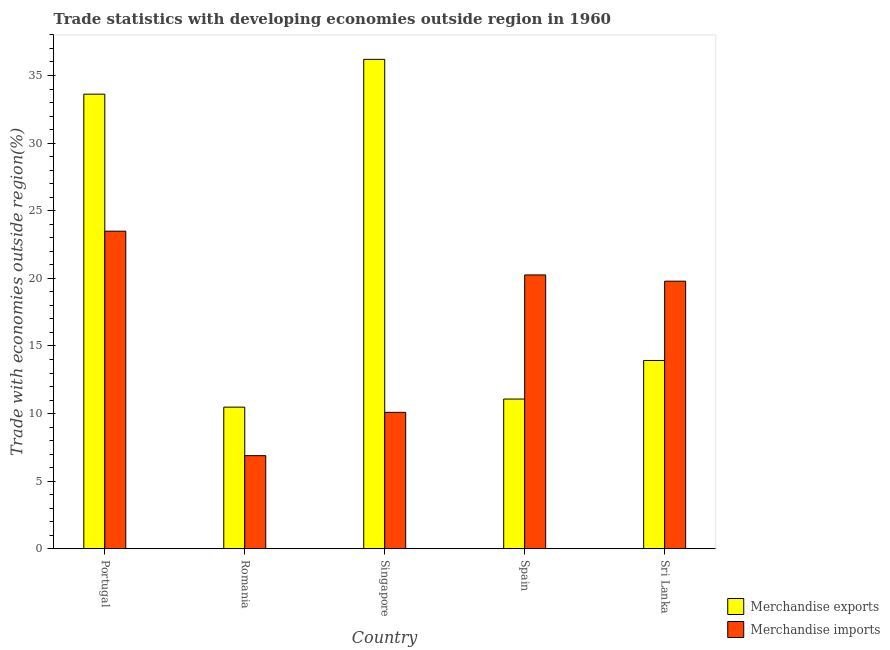How many bars are there on the 4th tick from the left?
Provide a short and direct response. 2. What is the label of the 5th group of bars from the left?
Provide a succinct answer. Sri Lanka. What is the merchandise imports in Sri Lanka?
Your answer should be very brief. 19.79. Across all countries, what is the maximum merchandise imports?
Keep it short and to the point. 23.49. Across all countries, what is the minimum merchandise exports?
Offer a very short reply. 10.48. In which country was the merchandise imports maximum?
Keep it short and to the point. Portugal. In which country was the merchandise imports minimum?
Your answer should be very brief. Romania. What is the total merchandise exports in the graph?
Your answer should be very brief. 105.3. What is the difference between the merchandise exports in Romania and that in Sri Lanka?
Your answer should be very brief. -3.45. What is the difference between the merchandise imports in Sri Lanka and the merchandise exports in Spain?
Offer a very short reply. 8.71. What is the average merchandise imports per country?
Keep it short and to the point. 16.1. What is the difference between the merchandise imports and merchandise exports in Sri Lanka?
Make the answer very short. 5.86. What is the ratio of the merchandise imports in Singapore to that in Sri Lanka?
Offer a terse response. 0.51. What is the difference between the highest and the second highest merchandise imports?
Provide a succinct answer. 3.24. What is the difference between the highest and the lowest merchandise imports?
Make the answer very short. 16.6. In how many countries, is the merchandise imports greater than the average merchandise imports taken over all countries?
Your response must be concise. 3. How many countries are there in the graph?
Make the answer very short. 5. What is the difference between two consecutive major ticks on the Y-axis?
Your answer should be compact. 5. Does the graph contain any zero values?
Provide a succinct answer. No. Where does the legend appear in the graph?
Keep it short and to the point. Bottom right. What is the title of the graph?
Offer a very short reply. Trade statistics with developing economies outside region in 1960. What is the label or title of the X-axis?
Give a very brief answer. Country. What is the label or title of the Y-axis?
Your answer should be compact. Trade with economies outside region(%). What is the Trade with economies outside region(%) of Merchandise exports in Portugal?
Keep it short and to the point. 33.62. What is the Trade with economies outside region(%) in Merchandise imports in Portugal?
Your answer should be compact. 23.49. What is the Trade with economies outside region(%) of Merchandise exports in Romania?
Offer a terse response. 10.48. What is the Trade with economies outside region(%) of Merchandise imports in Romania?
Offer a very short reply. 6.89. What is the Trade with economies outside region(%) in Merchandise exports in Singapore?
Your response must be concise. 36.19. What is the Trade with economies outside region(%) in Merchandise imports in Singapore?
Provide a short and direct response. 10.09. What is the Trade with economies outside region(%) of Merchandise exports in Spain?
Offer a terse response. 11.08. What is the Trade with economies outside region(%) of Merchandise imports in Spain?
Offer a terse response. 20.25. What is the Trade with economies outside region(%) of Merchandise exports in Sri Lanka?
Make the answer very short. 13.93. What is the Trade with economies outside region(%) of Merchandise imports in Sri Lanka?
Make the answer very short. 19.79. Across all countries, what is the maximum Trade with economies outside region(%) in Merchandise exports?
Provide a succinct answer. 36.19. Across all countries, what is the maximum Trade with economies outside region(%) in Merchandise imports?
Your response must be concise. 23.49. Across all countries, what is the minimum Trade with economies outside region(%) in Merchandise exports?
Your response must be concise. 10.48. Across all countries, what is the minimum Trade with economies outside region(%) of Merchandise imports?
Give a very brief answer. 6.89. What is the total Trade with economies outside region(%) in Merchandise exports in the graph?
Make the answer very short. 105.3. What is the total Trade with economies outside region(%) of Merchandise imports in the graph?
Keep it short and to the point. 80.52. What is the difference between the Trade with economies outside region(%) of Merchandise exports in Portugal and that in Romania?
Provide a short and direct response. 23.14. What is the difference between the Trade with economies outside region(%) in Merchandise imports in Portugal and that in Romania?
Your answer should be compact. 16.6. What is the difference between the Trade with economies outside region(%) of Merchandise exports in Portugal and that in Singapore?
Make the answer very short. -2.57. What is the difference between the Trade with economies outside region(%) of Merchandise imports in Portugal and that in Singapore?
Give a very brief answer. 13.4. What is the difference between the Trade with economies outside region(%) of Merchandise exports in Portugal and that in Spain?
Offer a terse response. 22.54. What is the difference between the Trade with economies outside region(%) in Merchandise imports in Portugal and that in Spain?
Offer a terse response. 3.24. What is the difference between the Trade with economies outside region(%) of Merchandise exports in Portugal and that in Sri Lanka?
Offer a very short reply. 19.69. What is the difference between the Trade with economies outside region(%) in Merchandise imports in Portugal and that in Sri Lanka?
Offer a terse response. 3.7. What is the difference between the Trade with economies outside region(%) in Merchandise exports in Romania and that in Singapore?
Offer a terse response. -25.72. What is the difference between the Trade with economies outside region(%) in Merchandise imports in Romania and that in Singapore?
Make the answer very short. -3.2. What is the difference between the Trade with economies outside region(%) of Merchandise exports in Romania and that in Spain?
Ensure brevity in your answer.  -0.6. What is the difference between the Trade with economies outside region(%) in Merchandise imports in Romania and that in Spain?
Ensure brevity in your answer.  -13.36. What is the difference between the Trade with economies outside region(%) in Merchandise exports in Romania and that in Sri Lanka?
Offer a very short reply. -3.45. What is the difference between the Trade with economies outside region(%) in Merchandise imports in Romania and that in Sri Lanka?
Your response must be concise. -12.9. What is the difference between the Trade with economies outside region(%) in Merchandise exports in Singapore and that in Spain?
Ensure brevity in your answer.  25.12. What is the difference between the Trade with economies outside region(%) in Merchandise imports in Singapore and that in Spain?
Your answer should be compact. -10.16. What is the difference between the Trade with economies outside region(%) of Merchandise exports in Singapore and that in Sri Lanka?
Offer a terse response. 22.26. What is the difference between the Trade with economies outside region(%) of Merchandise imports in Singapore and that in Sri Lanka?
Provide a short and direct response. -9.7. What is the difference between the Trade with economies outside region(%) in Merchandise exports in Spain and that in Sri Lanka?
Your response must be concise. -2.85. What is the difference between the Trade with economies outside region(%) in Merchandise imports in Spain and that in Sri Lanka?
Offer a terse response. 0.46. What is the difference between the Trade with economies outside region(%) in Merchandise exports in Portugal and the Trade with economies outside region(%) in Merchandise imports in Romania?
Your response must be concise. 26.73. What is the difference between the Trade with economies outside region(%) of Merchandise exports in Portugal and the Trade with economies outside region(%) of Merchandise imports in Singapore?
Make the answer very short. 23.53. What is the difference between the Trade with economies outside region(%) in Merchandise exports in Portugal and the Trade with economies outside region(%) in Merchandise imports in Spain?
Offer a terse response. 13.37. What is the difference between the Trade with economies outside region(%) in Merchandise exports in Portugal and the Trade with economies outside region(%) in Merchandise imports in Sri Lanka?
Your answer should be very brief. 13.83. What is the difference between the Trade with economies outside region(%) of Merchandise exports in Romania and the Trade with economies outside region(%) of Merchandise imports in Singapore?
Your answer should be very brief. 0.39. What is the difference between the Trade with economies outside region(%) in Merchandise exports in Romania and the Trade with economies outside region(%) in Merchandise imports in Spain?
Make the answer very short. -9.78. What is the difference between the Trade with economies outside region(%) in Merchandise exports in Romania and the Trade with economies outside region(%) in Merchandise imports in Sri Lanka?
Offer a terse response. -9.31. What is the difference between the Trade with economies outside region(%) of Merchandise exports in Singapore and the Trade with economies outside region(%) of Merchandise imports in Spain?
Provide a short and direct response. 15.94. What is the difference between the Trade with economies outside region(%) of Merchandise exports in Singapore and the Trade with economies outside region(%) of Merchandise imports in Sri Lanka?
Keep it short and to the point. 16.4. What is the difference between the Trade with economies outside region(%) in Merchandise exports in Spain and the Trade with economies outside region(%) in Merchandise imports in Sri Lanka?
Offer a terse response. -8.71. What is the average Trade with economies outside region(%) in Merchandise exports per country?
Give a very brief answer. 21.06. What is the average Trade with economies outside region(%) in Merchandise imports per country?
Offer a very short reply. 16.1. What is the difference between the Trade with economies outside region(%) of Merchandise exports and Trade with economies outside region(%) of Merchandise imports in Portugal?
Ensure brevity in your answer.  10.13. What is the difference between the Trade with economies outside region(%) of Merchandise exports and Trade with economies outside region(%) of Merchandise imports in Romania?
Your answer should be very brief. 3.59. What is the difference between the Trade with economies outside region(%) in Merchandise exports and Trade with economies outside region(%) in Merchandise imports in Singapore?
Keep it short and to the point. 26.1. What is the difference between the Trade with economies outside region(%) in Merchandise exports and Trade with economies outside region(%) in Merchandise imports in Spain?
Provide a short and direct response. -9.18. What is the difference between the Trade with economies outside region(%) in Merchandise exports and Trade with economies outside region(%) in Merchandise imports in Sri Lanka?
Provide a short and direct response. -5.86. What is the ratio of the Trade with economies outside region(%) of Merchandise exports in Portugal to that in Romania?
Offer a terse response. 3.21. What is the ratio of the Trade with economies outside region(%) in Merchandise imports in Portugal to that in Romania?
Your answer should be very brief. 3.41. What is the ratio of the Trade with economies outside region(%) of Merchandise exports in Portugal to that in Singapore?
Keep it short and to the point. 0.93. What is the ratio of the Trade with economies outside region(%) in Merchandise imports in Portugal to that in Singapore?
Your response must be concise. 2.33. What is the ratio of the Trade with economies outside region(%) in Merchandise exports in Portugal to that in Spain?
Your answer should be compact. 3.03. What is the ratio of the Trade with economies outside region(%) of Merchandise imports in Portugal to that in Spain?
Give a very brief answer. 1.16. What is the ratio of the Trade with economies outside region(%) in Merchandise exports in Portugal to that in Sri Lanka?
Give a very brief answer. 2.41. What is the ratio of the Trade with economies outside region(%) in Merchandise imports in Portugal to that in Sri Lanka?
Offer a very short reply. 1.19. What is the ratio of the Trade with economies outside region(%) of Merchandise exports in Romania to that in Singapore?
Offer a very short reply. 0.29. What is the ratio of the Trade with economies outside region(%) in Merchandise imports in Romania to that in Singapore?
Your answer should be very brief. 0.68. What is the ratio of the Trade with economies outside region(%) in Merchandise exports in Romania to that in Spain?
Your answer should be compact. 0.95. What is the ratio of the Trade with economies outside region(%) in Merchandise imports in Romania to that in Spain?
Offer a very short reply. 0.34. What is the ratio of the Trade with economies outside region(%) in Merchandise exports in Romania to that in Sri Lanka?
Your answer should be compact. 0.75. What is the ratio of the Trade with economies outside region(%) in Merchandise imports in Romania to that in Sri Lanka?
Provide a succinct answer. 0.35. What is the ratio of the Trade with economies outside region(%) in Merchandise exports in Singapore to that in Spain?
Give a very brief answer. 3.27. What is the ratio of the Trade with economies outside region(%) of Merchandise imports in Singapore to that in Spain?
Offer a very short reply. 0.5. What is the ratio of the Trade with economies outside region(%) of Merchandise exports in Singapore to that in Sri Lanka?
Provide a succinct answer. 2.6. What is the ratio of the Trade with economies outside region(%) in Merchandise imports in Singapore to that in Sri Lanka?
Give a very brief answer. 0.51. What is the ratio of the Trade with economies outside region(%) of Merchandise exports in Spain to that in Sri Lanka?
Your answer should be very brief. 0.8. What is the ratio of the Trade with economies outside region(%) of Merchandise imports in Spain to that in Sri Lanka?
Your answer should be very brief. 1.02. What is the difference between the highest and the second highest Trade with economies outside region(%) in Merchandise exports?
Your answer should be very brief. 2.57. What is the difference between the highest and the second highest Trade with economies outside region(%) in Merchandise imports?
Offer a very short reply. 3.24. What is the difference between the highest and the lowest Trade with economies outside region(%) in Merchandise exports?
Give a very brief answer. 25.72. What is the difference between the highest and the lowest Trade with economies outside region(%) of Merchandise imports?
Your response must be concise. 16.6. 